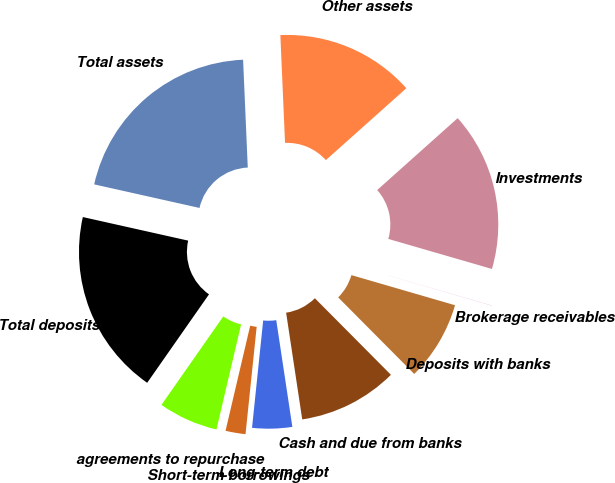Convert chart to OTSL. <chart><loc_0><loc_0><loc_500><loc_500><pie_chart><fcel>Cash and due from banks<fcel>Deposits with banks<fcel>Brokerage receivables<fcel>Investments<fcel>Other assets<fcel>Total assets<fcel>Total deposits<fcel>agreements to repurchase<fcel>Short-term borrowings<fcel>Long-term debt<nl><fcel>10.06%<fcel>8.05%<fcel>0.01%<fcel>16.09%<fcel>14.08%<fcel>20.8%<fcel>18.79%<fcel>6.04%<fcel>2.02%<fcel>4.03%<nl></chart> 